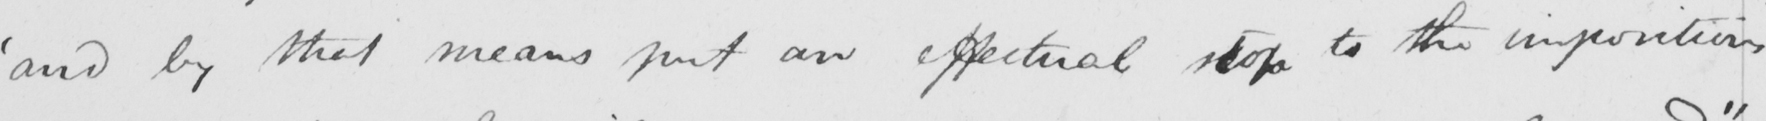What does this handwritten line say? ' and by that means put an effectual stop to the impositions 